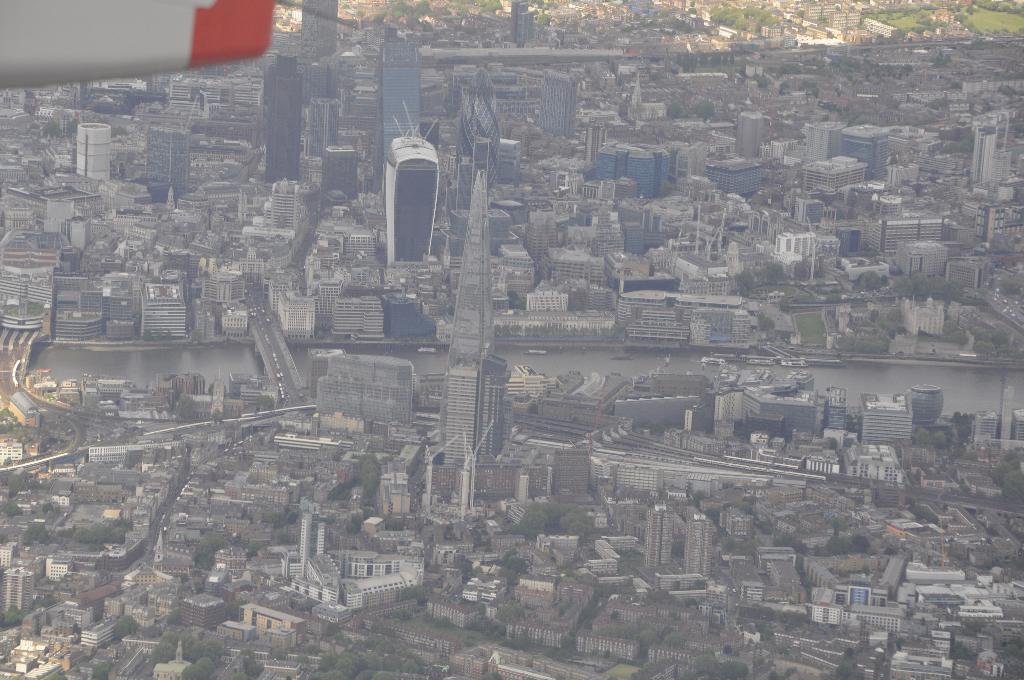Could you give a brief overview of what you see in this image? In this image we can see a view from the height and on the ground there are so many buildings. 